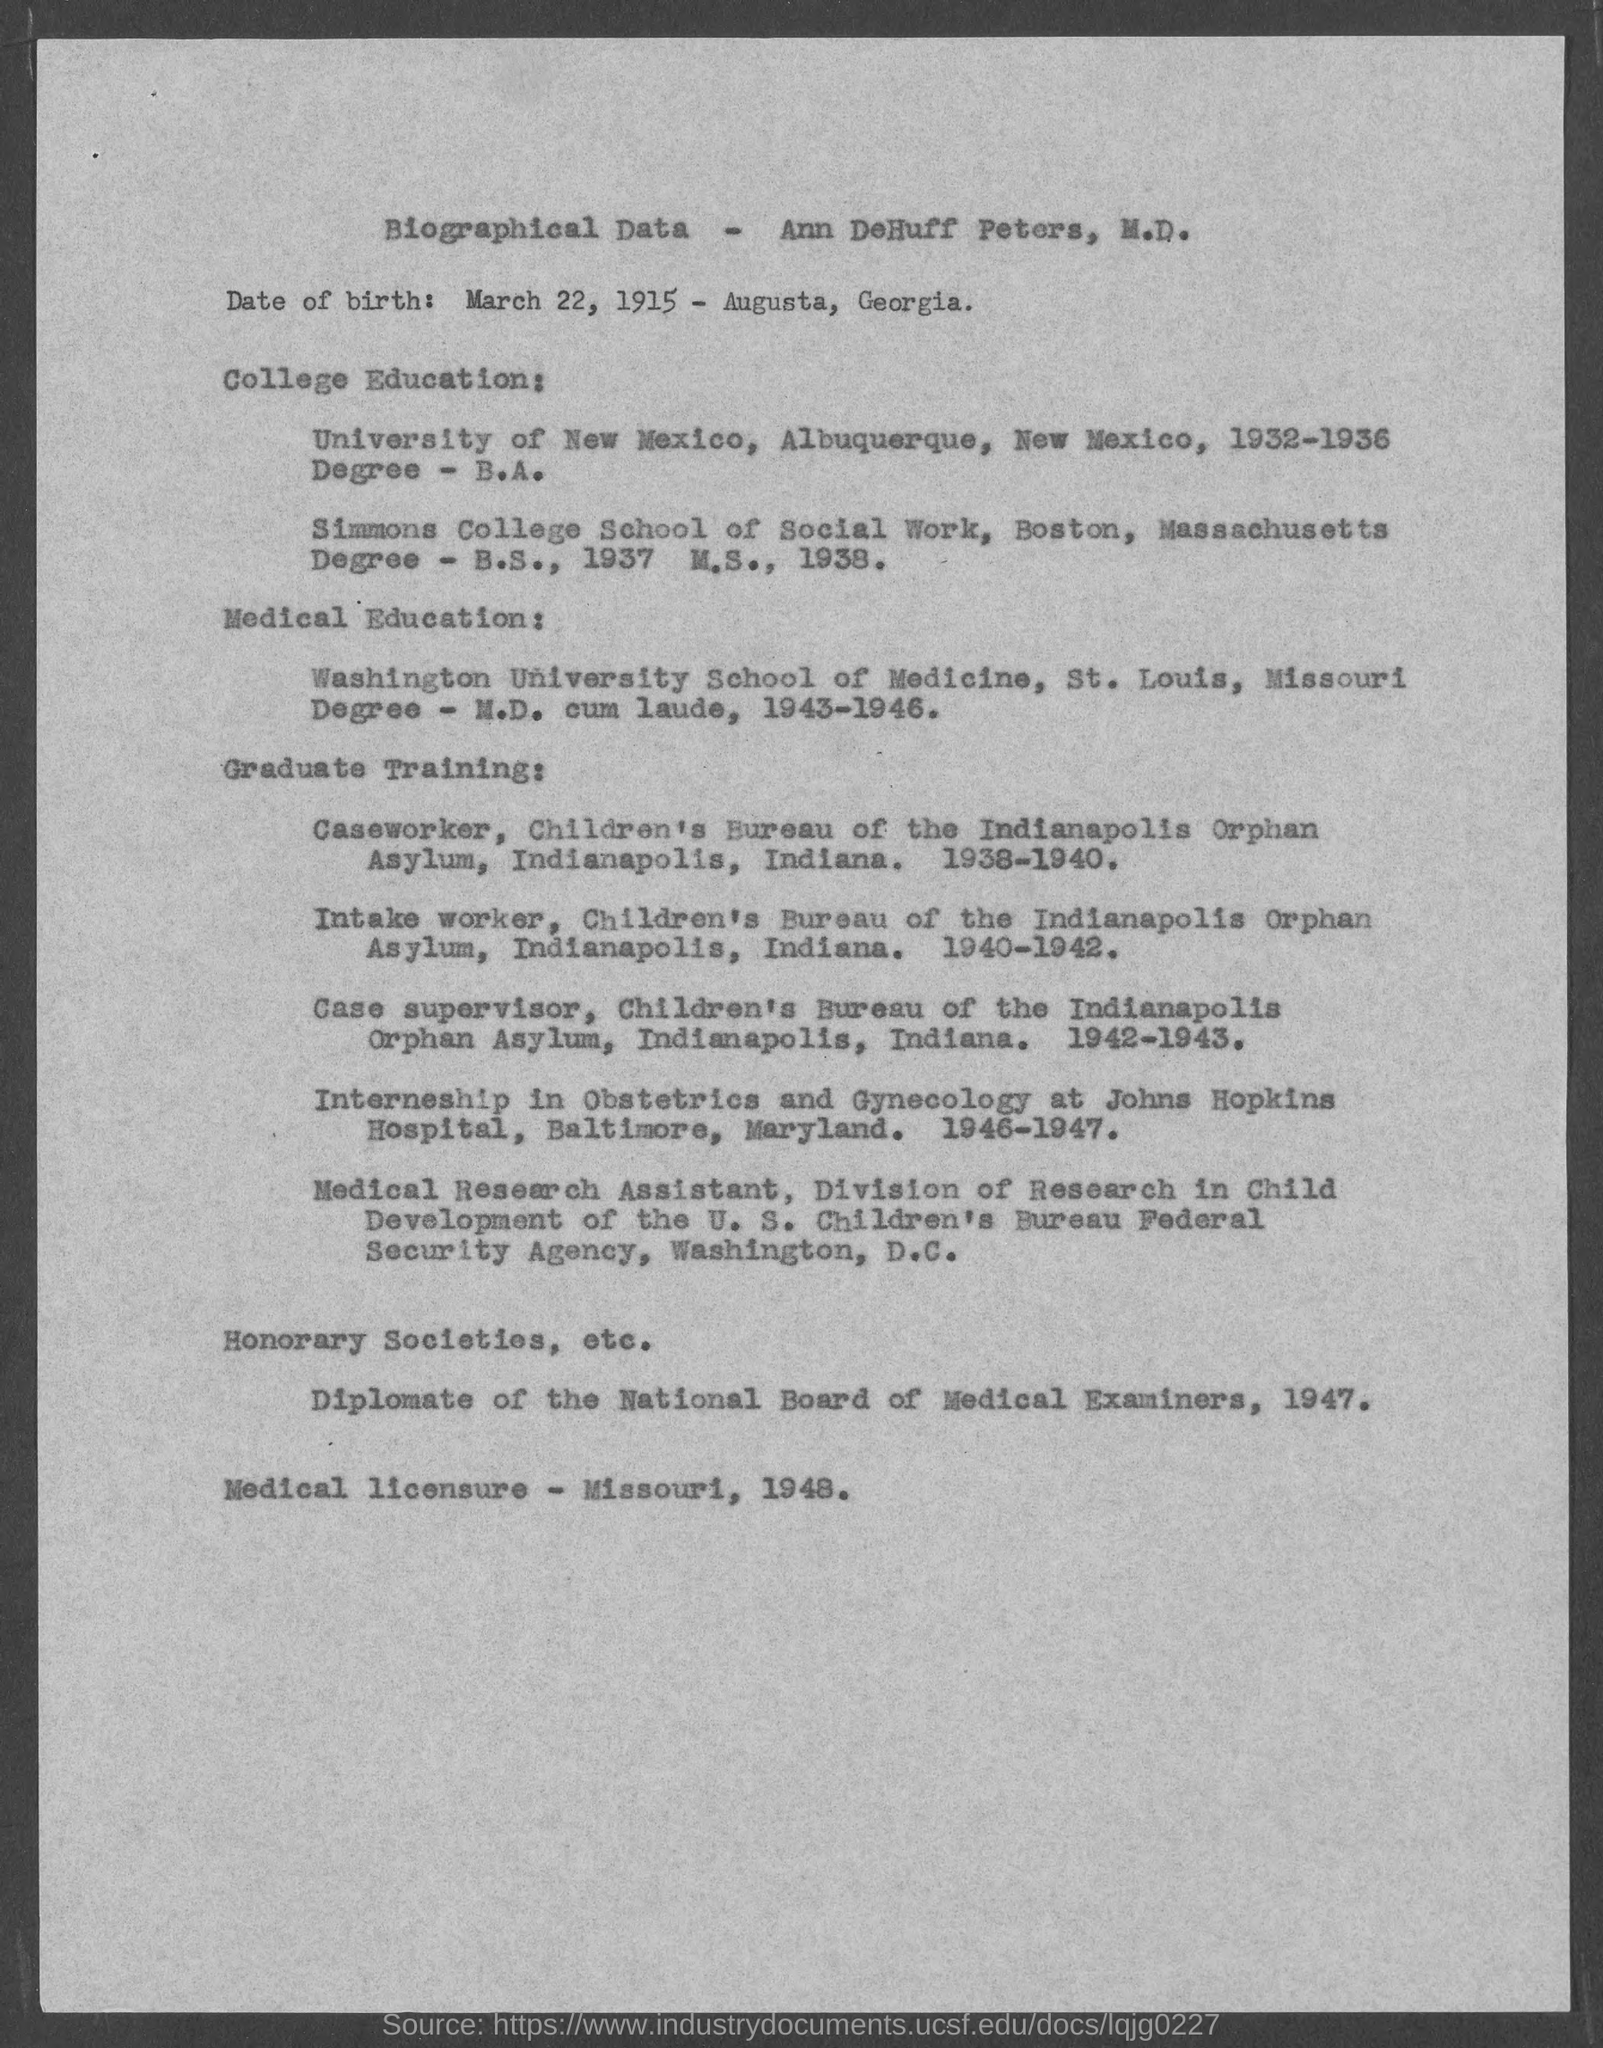Who's biographical data is given here?
Offer a very short reply. Ann DeHuff Peters, M.D. In which university, Ann DeHuff Peters, M.D. completed B.A. degree?
Offer a terse response. University of New Mexico. When did Ann DeHuff Peters, M.D. got the medical licensure?
Offer a terse response. 1948. 